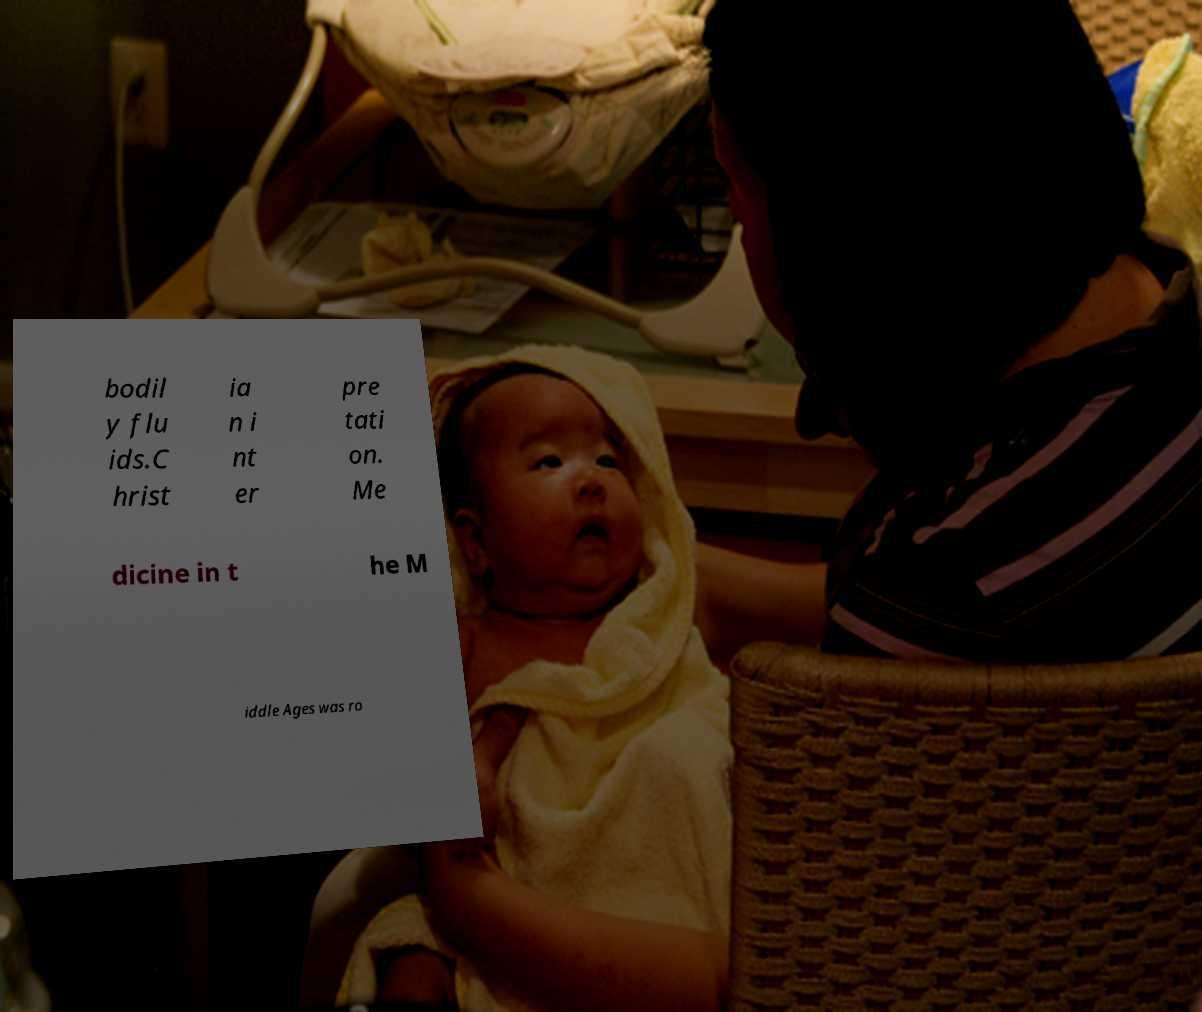Can you accurately transcribe the text from the provided image for me? bodil y flu ids.C hrist ia n i nt er pre tati on. Me dicine in t he M iddle Ages was ro 